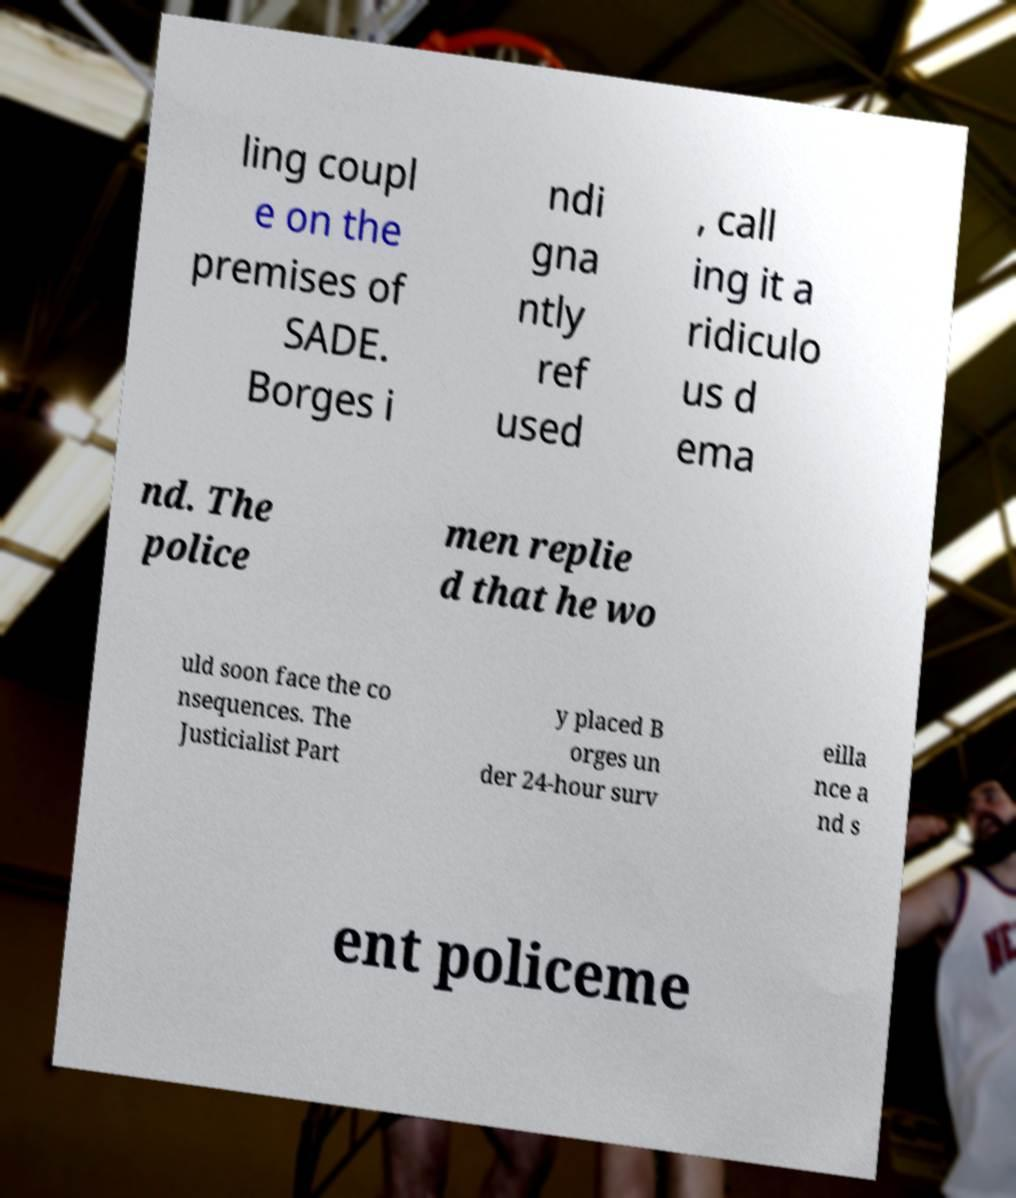Can you accurately transcribe the text from the provided image for me? ling coupl e on the premises of SADE. Borges i ndi gna ntly ref used , call ing it a ridiculo us d ema nd. The police men replie d that he wo uld soon face the co nsequences. The Justicialist Part y placed B orges un der 24-hour surv eilla nce a nd s ent policeme 